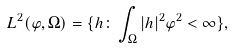<formula> <loc_0><loc_0><loc_500><loc_500>L ^ { 2 } ( \varphi , \Omega ) = \{ h \colon \int _ { \Omega } | h | ^ { 2 } \varphi ^ { 2 } < \infty \} ,</formula> 